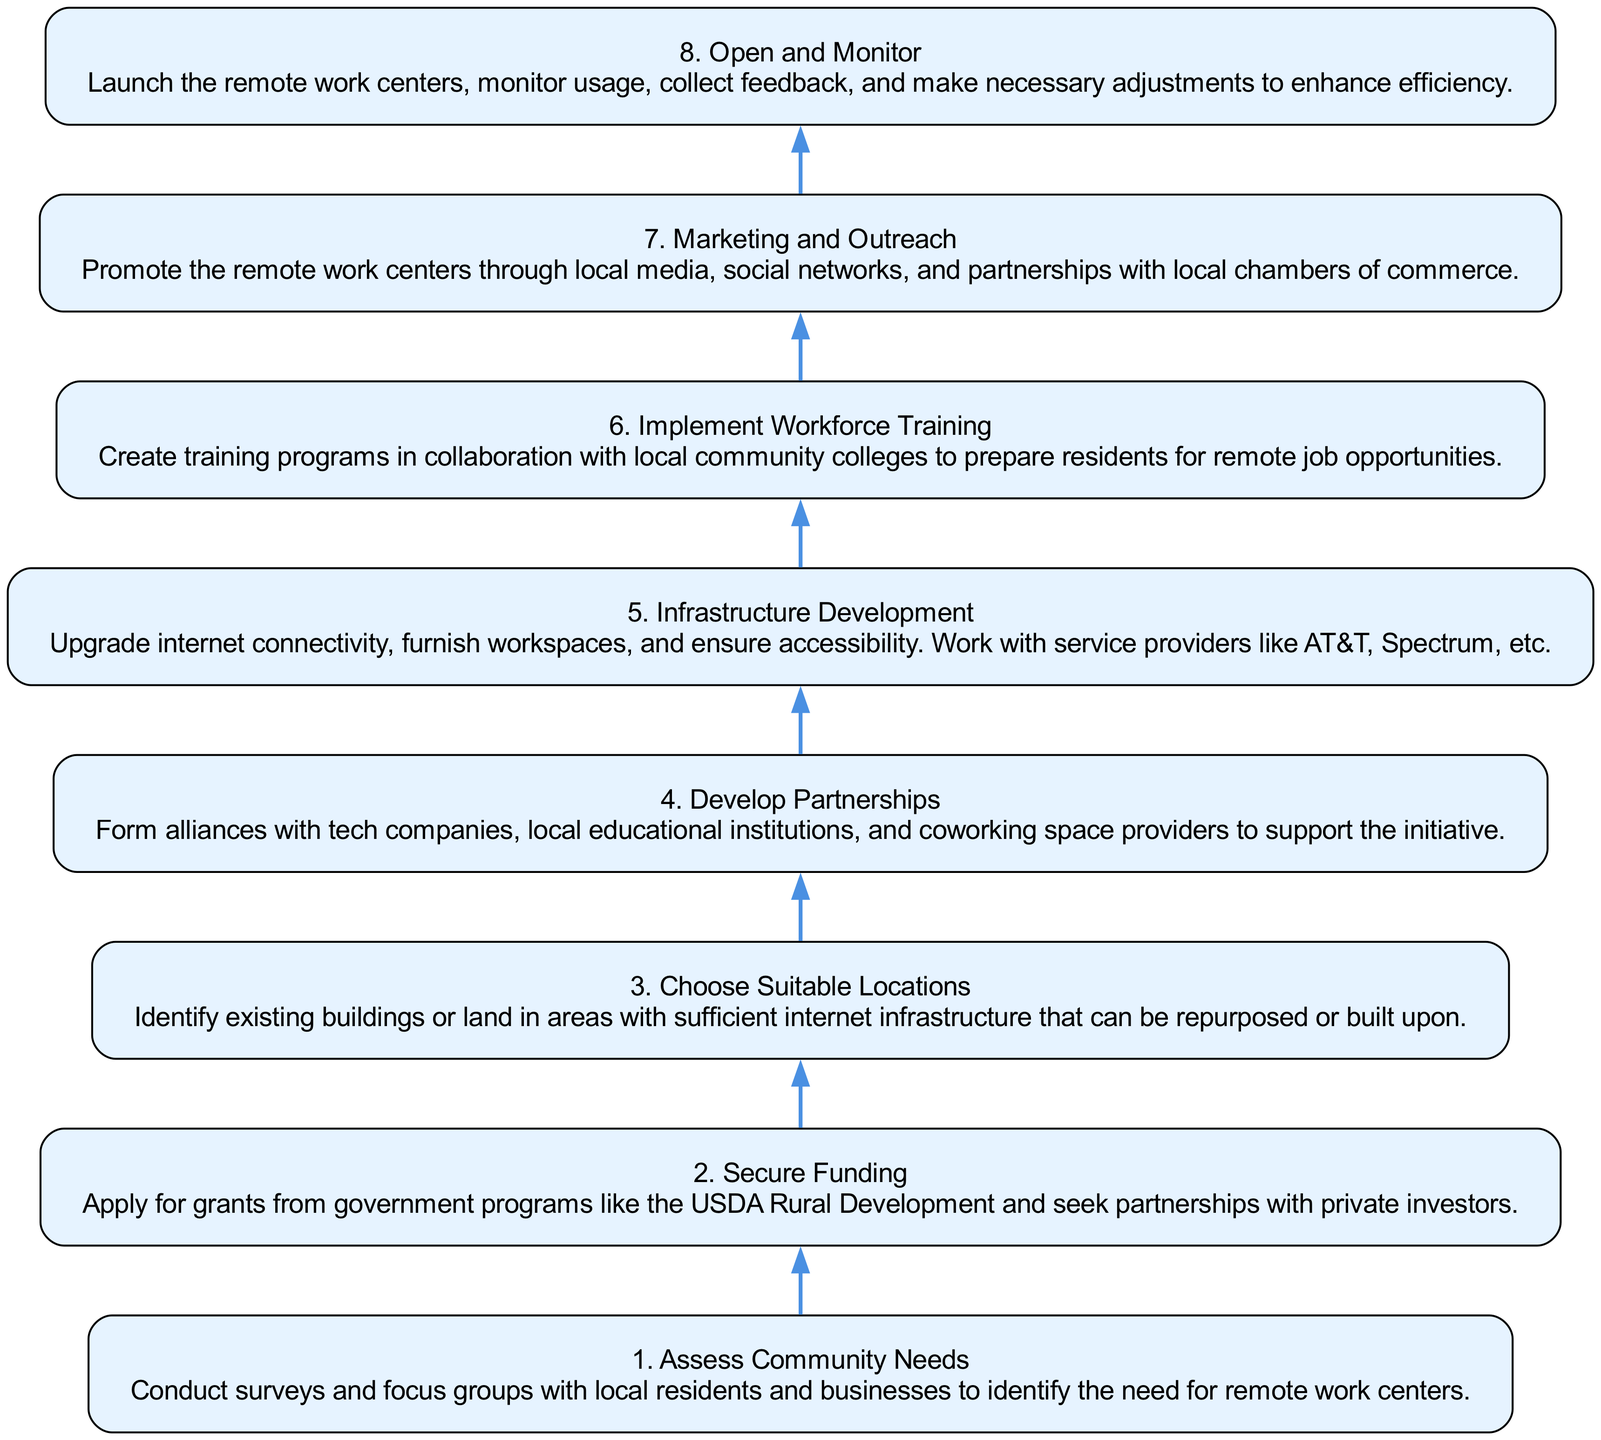What is the first step in establishing remote work centers? The diagram indicates that the first step is to "Assess Community Needs." This is the initial phase where local residents and businesses are surveyed to understand their requirements.
Answer: Assess Community Needs How many main steps are shown in the diagram? By reviewing the nodes listed in the diagram, there are a total of eight distinct steps involved in the process of establishing remote work centers.
Answer: 8 What do the steps lead to after Implement Workforce Training? After the "Implement Workforce Training" step, the next step as per the diagram is "Marketing and Outreach," implying that training is followed by efforts to promote the remote work centers.
Answer: Marketing and Outreach Which step involves collaboration with local educational institutions? The step that specifies collaboration with local educational institutions is "Implement Workforce Training," as it mentions creating training programs in cooperation with these institutions.
Answer: Implement Workforce Training What is the last step in the process? According to the diagram's flow, the final step is "Open and Monitor," where the remote work centers are launched and feedback is collected to improve efficiency.
Answer: Open and Monitor How does the step "Develop Partnerships" relate to "Secure Funding"? "Develop Partnerships" is the fourth step and it follows "Secure Funding," suggesting that securing financial resources from grants and investors may often necessitate forming partnerships for successful implementation.
Answer: It follows Which step focuses on user experience evaluation after opening the centers? The step centered on user experience evaluation after opening is "Open and Monitor," where monitoring of usage and collection of feedback occurs to make necessary adjustments.
Answer: Open and Monitor What type of organizations need to be involved in establishing infrastructure development? The "Infrastructure Development" step highlights the need to work with service providers like AT&T and Spectrum, indicating that telecommunications companies must be involved to enhance internet connectivity.
Answer: Telecommunications companies 